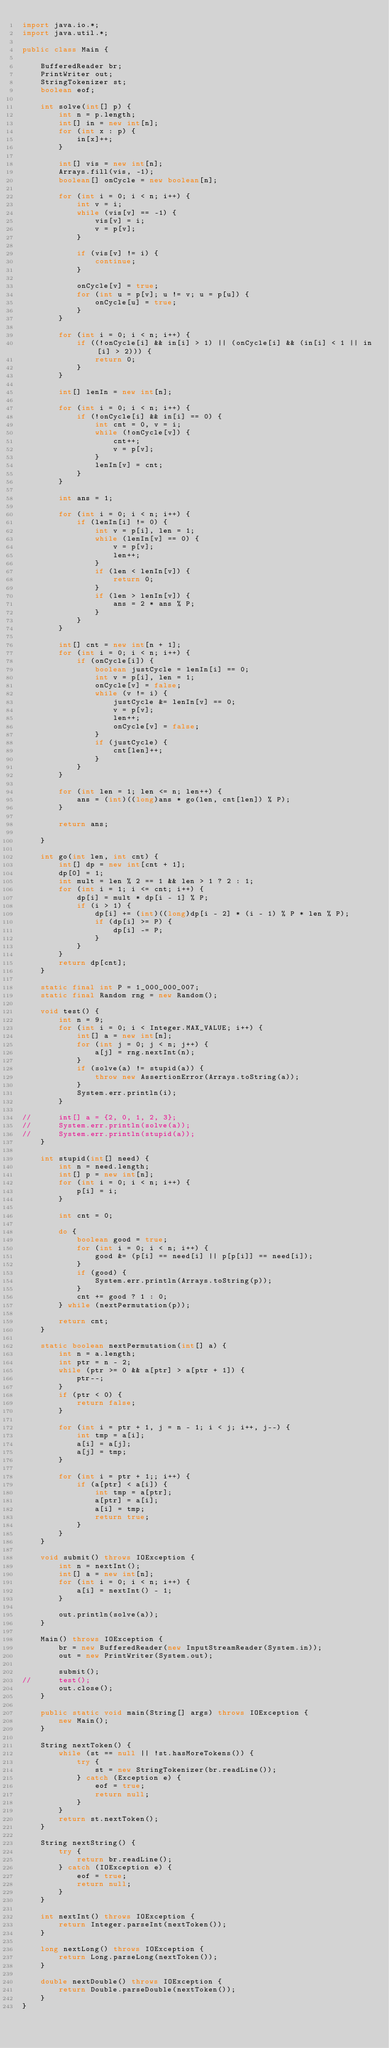Convert code to text. <code><loc_0><loc_0><loc_500><loc_500><_Java_>import java.io.*;
import java.util.*;

public class Main {

	BufferedReader br;
	PrintWriter out;
	StringTokenizer st;
	boolean eof;

	int solve(int[] p) {
		int n = p.length;
		int[] in = new int[n];
		for (int x : p) {
			in[x]++;
		}
		
		int[] vis = new int[n];
		Arrays.fill(vis, -1);
		boolean[] onCycle = new boolean[n];
		
		for (int i = 0; i < n; i++) {
			int v = i;
			while (vis[v] == -1) {
				vis[v] = i;
				v = p[v];
			}
			
			if (vis[v] != i) {
				continue;
			}
			
			onCycle[v] = true;
			for (int u = p[v]; u != v; u = p[u]) {
				onCycle[u] = true;
			}
		}
		
		for (int i = 0; i < n; i++) {
			if ((!onCycle[i] && in[i] > 1) || (onCycle[i] && (in[i] < 1 || in[i] > 2))) {
				return 0;
			}
		}
		
		int[] lenIn = new int[n];
		
		for (int i = 0; i < n; i++) {
			if (!onCycle[i] && in[i] == 0) {
				int cnt = 0, v = i;
				while (!onCycle[v]) {
					cnt++;
					v = p[v];
				}
				lenIn[v] = cnt;
			}
		}
		
		int ans = 1;
		
		for (int i = 0; i < n; i++) {
			if (lenIn[i] != 0) {
				int v = p[i], len = 1;
				while (lenIn[v] == 0) {
					v = p[v];
					len++;
				}
				if (len < lenIn[v]) {
					return 0;
				}
				if (len > lenIn[v]) {
					ans = 2 * ans % P;
				}
			}
		}
		
		int[] cnt = new int[n + 1];
		for (int i = 0; i < n; i++) {
			if (onCycle[i]) {
				boolean justCycle = lenIn[i] == 0;
				int v = p[i], len = 1;
				onCycle[v] = false;
				while (v != i) {
					justCycle &= lenIn[v] == 0;
					v = p[v];
					len++;
					onCycle[v] = false;
				}
				if (justCycle) {
					cnt[len]++;
				}
			}
		}
		
		for (int len = 1; len <= n; len++) {
			ans = (int)((long)ans * go(len, cnt[len]) % P);
		}
		
		return ans;
		
	}
	
	int go(int len, int cnt) {
		int[] dp = new int[cnt + 1];
		dp[0] = 1;
		int mult = len % 2 == 1 && len > 1 ? 2 : 1;
		for (int i = 1; i <= cnt; i++) {
			dp[i] = mult * dp[i - 1] % P;
			if (i > 1) {
				dp[i] += (int)((long)dp[i - 2] * (i - 1) % P * len % P);
				if (dp[i] >= P) {
					dp[i] -= P;
				}
			}
		}
		return dp[cnt];
	}
	
	static final int P = 1_000_000_007;
	static final Random rng = new Random();
	
	void test() {
		int n = 9;
		for (int i = 0; i < Integer.MAX_VALUE; i++) {
			int[] a = new int[n];
			for (int j = 0; j < n; j++) {
				a[j] = rng.nextInt(n);
			}
			if (solve(a) != stupid(a)) {
				throw new AssertionError(Arrays.toString(a));
			}
			System.err.println(i);
		}
		
//		int[] a = {2, 0, 1, 2, 3};
//		System.err.println(solve(a));
//		System.err.println(stupid(a));
	}

	int stupid(int[] need) {
		int n = need.length;
		int[] p = new int[n];
		for (int i = 0; i < n; i++) {
			p[i] = i;
		}

		int cnt = 0;

		do {
			boolean good = true;
			for (int i = 0; i < n; i++) {
				good &= (p[i] == need[i] || p[p[i]] == need[i]);
			}
			if (good) {
				System.err.println(Arrays.toString(p));
			}
			cnt += good ? 1 : 0;
		} while (nextPermutation(p));
		
		return cnt;
	}

	static boolean nextPermutation(int[] a) {
		int n = a.length;
		int ptr = n - 2;
		while (ptr >= 0 && a[ptr] > a[ptr + 1]) {
			ptr--;
		}
		if (ptr < 0) {
			return false;
		}

		for (int i = ptr + 1, j = n - 1; i < j; i++, j--) {
			int tmp = a[i];
			a[i] = a[j];
			a[j] = tmp;
		}

		for (int i = ptr + 1;; i++) {
			if (a[ptr] < a[i]) {
				int tmp = a[ptr];
				a[ptr] = a[i];
				a[i] = tmp;
				return true;
			}
		}
	}

	void submit() throws IOException {
		int n = nextInt();
		int[] a = new int[n];
		for (int i = 0; i < n; i++) {
			a[i] = nextInt() - 1;
		}
		
		out.println(solve(a));
	}

	Main() throws IOException {
		br = new BufferedReader(new InputStreamReader(System.in));
		out = new PrintWriter(System.out);

		submit();
//		test();
		out.close();
	}

	public static void main(String[] args) throws IOException {
		new Main();
	}

	String nextToken() {
		while (st == null || !st.hasMoreTokens()) {
			try {
				st = new StringTokenizer(br.readLine());
			} catch (Exception e) {
				eof = true;
				return null;
			}
		}
		return st.nextToken();
	}

	String nextString() {
		try {
			return br.readLine();
		} catch (IOException e) {
			eof = true;
			return null;
		}
	}

	int nextInt() throws IOException {
		return Integer.parseInt(nextToken());
	}

	long nextLong() throws IOException {
		return Long.parseLong(nextToken());
	}

	double nextDouble() throws IOException {
		return Double.parseDouble(nextToken());
	}
}</code> 